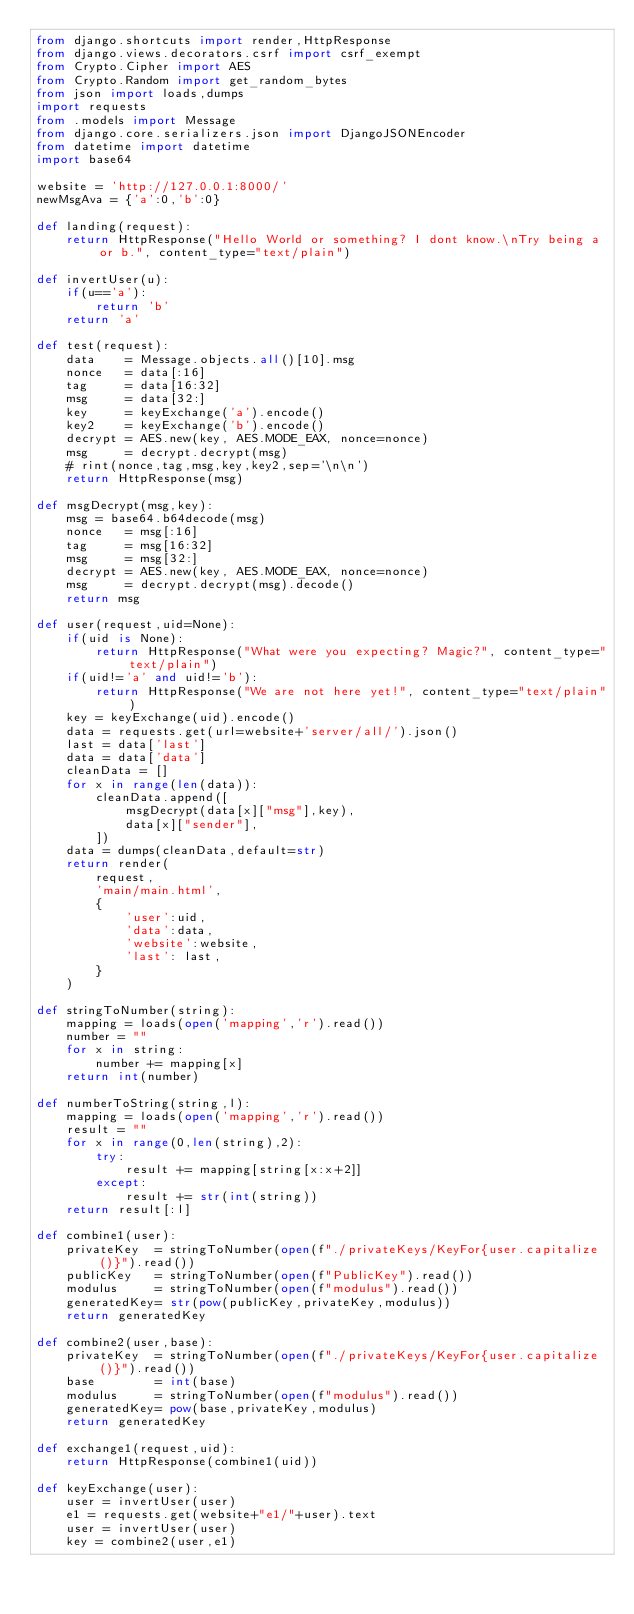<code> <loc_0><loc_0><loc_500><loc_500><_Python_>from django.shortcuts import render,HttpResponse
from django.views.decorators.csrf import csrf_exempt
from Crypto.Cipher import AES
from Crypto.Random import get_random_bytes
from json import loads,dumps
import requests
from .models import Message
from django.core.serializers.json import DjangoJSONEncoder
from datetime import datetime
import base64

website = 'http://127.0.0.1:8000/'
newMsgAva = {'a':0,'b':0}

def landing(request):
	return HttpResponse("Hello World or something? I dont know.\nTry being a or b.", content_type="text/plain")

def invertUser(u):
	if(u=='a'):
		return 'b'
	return 'a'

def test(request):
	data	= Message.objects.all()[10].msg
	nonce 	= data[:16]
	tag 	= data[16:32]
	msg		= data[32:]
	key 	= keyExchange('a').encode()
	key2	= keyExchange('b').encode()
	decrypt	= AES.new(key, AES.MODE_EAX, nonce=nonce)
	msg 	= decrypt.decrypt(msg)
	# rint(nonce,tag,msg,key,key2,sep='\n\n')
	return HttpResponse(msg)

def msgDecrypt(msg,key):
	msg = base64.b64decode(msg)
	nonce 	= msg[:16]
	tag 	= msg[16:32]
	msg		= msg[32:]
	decrypt	= AES.new(key, AES.MODE_EAX, nonce=nonce)
	msg 	= decrypt.decrypt(msg).decode()
	return msg

def user(request,uid=None):
	if(uid is None):
		return HttpResponse("What were you expecting? Magic?", content_type="text/plain")
	if(uid!='a' and uid!='b'):
		return HttpResponse("We are not here yet!", content_type="text/plain")
	key = keyExchange(uid).encode()
	data = requests.get(url=website+'server/all/').json()
	last = data['last']
	data = data['data']
	cleanData = []
	for x in range(len(data)):
		cleanData.append([
			msgDecrypt(data[x]["msg"],key),
			data[x]["sender"],
		])
	data = dumps(cleanData,default=str)
	return render(
		request,
		'main/main.html',
		{
			'user':uid,
			'data':data,
			'website':website,
			'last': last,
		}
	)

def stringToNumber(string):
	mapping = loads(open('mapping','r').read())
	number = ""
	for x in string:
		number += mapping[x]
	return int(number)

def numberToString(string,l):
	mapping = loads(open('mapping','r').read())
	result = ""
	for x in range(0,len(string),2):
		try:
			result += mapping[string[x:x+2]]
		except:
			result += str(int(string))
	return result[:l]

def combine1(user):
	privateKey 	= stringToNumber(open(f"./privateKeys/KeyFor{user.capitalize()}").read())
	publicKey	= stringToNumber(open(f"PublicKey").read())
	modulus		= stringToNumber(open(f"modulus").read())
	generatedKey= str(pow(publicKey,privateKey,modulus))
	return generatedKey

def combine2(user,base):
	privateKey 	= stringToNumber(open(f"./privateKeys/KeyFor{user.capitalize()}").read())
	base 		= int(base)
	modulus		= stringToNumber(open(f"modulus").read())
	generatedKey= pow(base,privateKey,modulus)
	return generatedKey

def exchange1(request,uid):
	return HttpResponse(combine1(uid))

def keyExchange(user):
	user = invertUser(user)
	e1 = requests.get(website+"e1/"+user).text
	user = invertUser(user)
	key = combine2(user,e1)</code> 